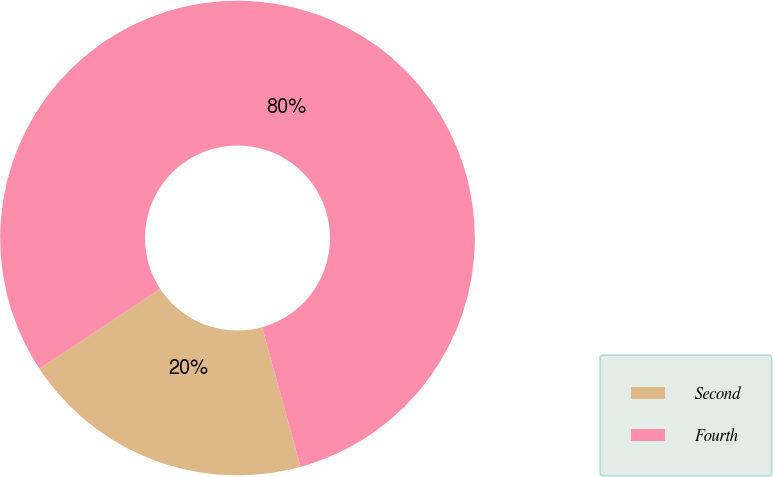<chart> <loc_0><loc_0><loc_500><loc_500><pie_chart><fcel>Second<fcel>Fourth<nl><fcel>20.0%<fcel>80.0%<nl></chart> 